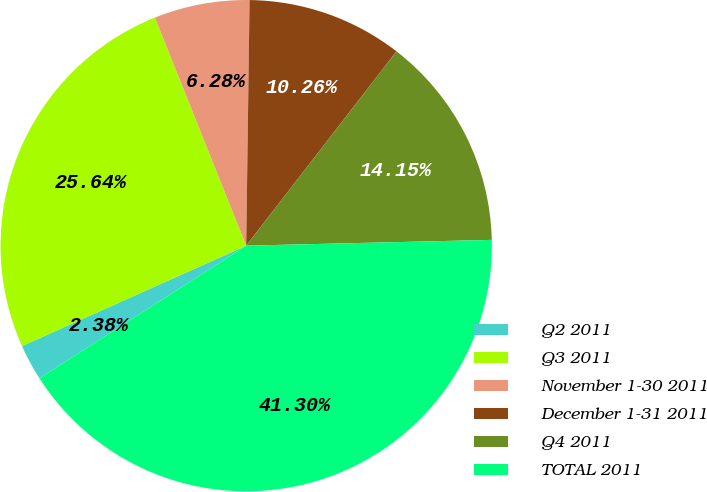Convert chart to OTSL. <chart><loc_0><loc_0><loc_500><loc_500><pie_chart><fcel>Q2 2011<fcel>Q3 2011<fcel>November 1-30 2011<fcel>December 1-31 2011<fcel>Q4 2011<fcel>TOTAL 2011<nl><fcel>2.38%<fcel>25.64%<fcel>6.28%<fcel>10.26%<fcel>14.15%<fcel>41.3%<nl></chart> 